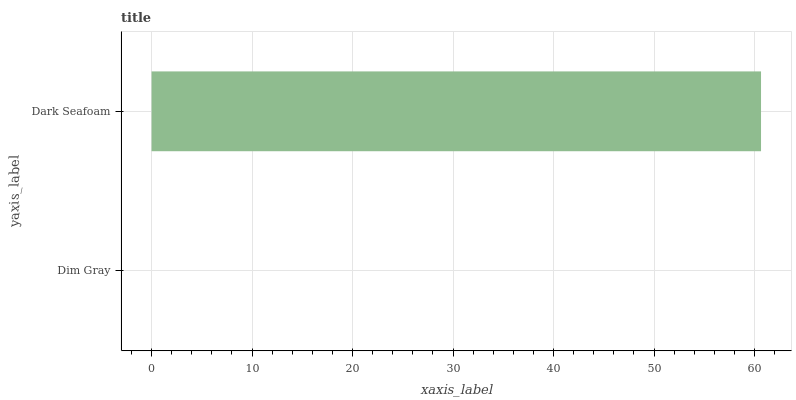Is Dim Gray the minimum?
Answer yes or no. Yes. Is Dark Seafoam the maximum?
Answer yes or no. Yes. Is Dark Seafoam the minimum?
Answer yes or no. No. Is Dark Seafoam greater than Dim Gray?
Answer yes or no. Yes. Is Dim Gray less than Dark Seafoam?
Answer yes or no. Yes. Is Dim Gray greater than Dark Seafoam?
Answer yes or no. No. Is Dark Seafoam less than Dim Gray?
Answer yes or no. No. Is Dark Seafoam the high median?
Answer yes or no. Yes. Is Dim Gray the low median?
Answer yes or no. Yes. Is Dim Gray the high median?
Answer yes or no. No. Is Dark Seafoam the low median?
Answer yes or no. No. 